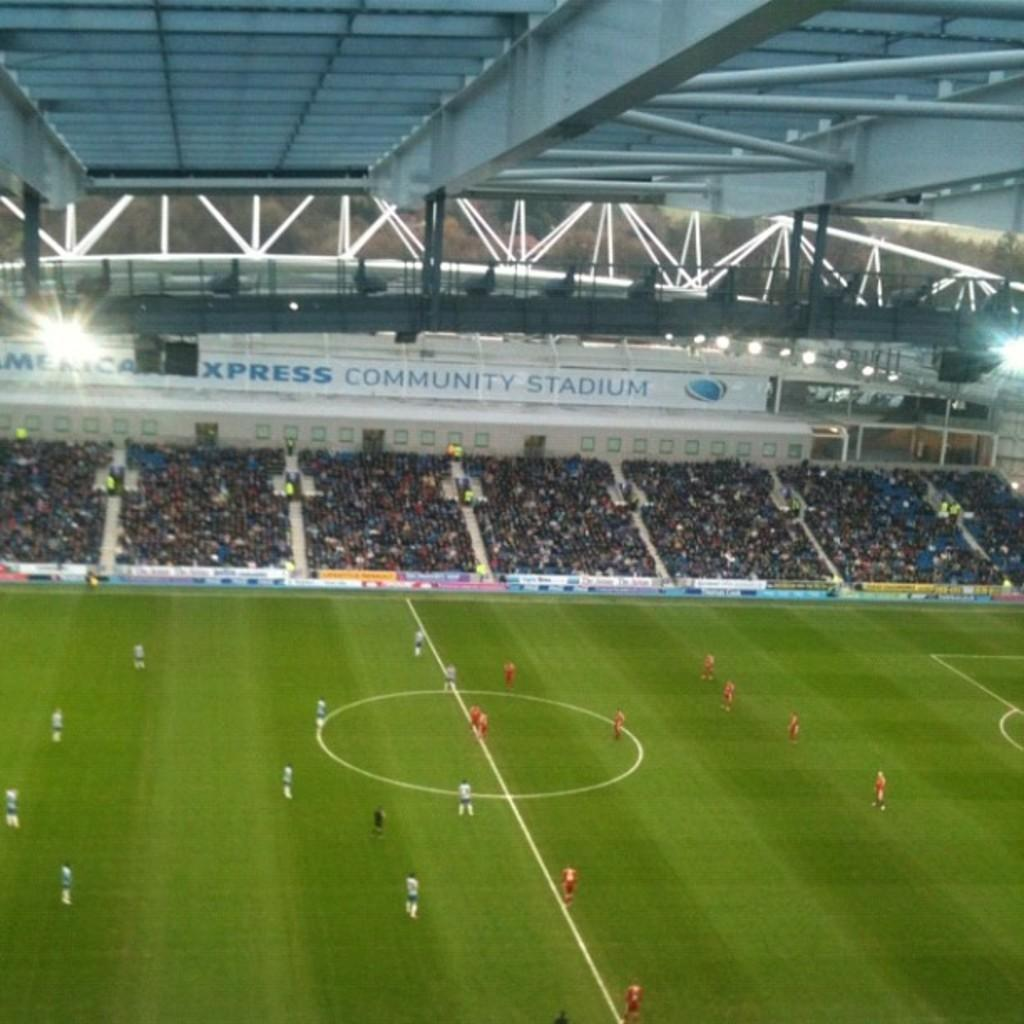<image>
Create a compact narrative representing the image presented. a football stadium with community stadium written above the spectator seats. 